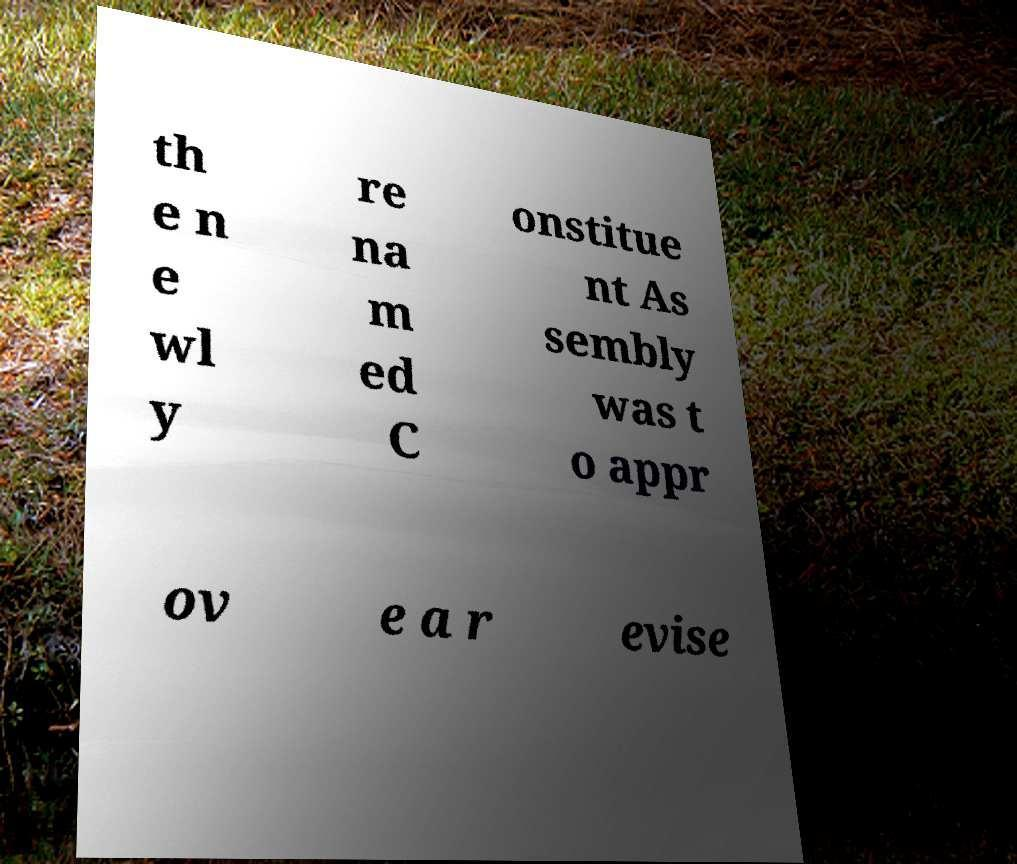What messages or text are displayed in this image? I need them in a readable, typed format. th e n e wl y re na m ed C onstitue nt As sembly was t o appr ov e a r evise 